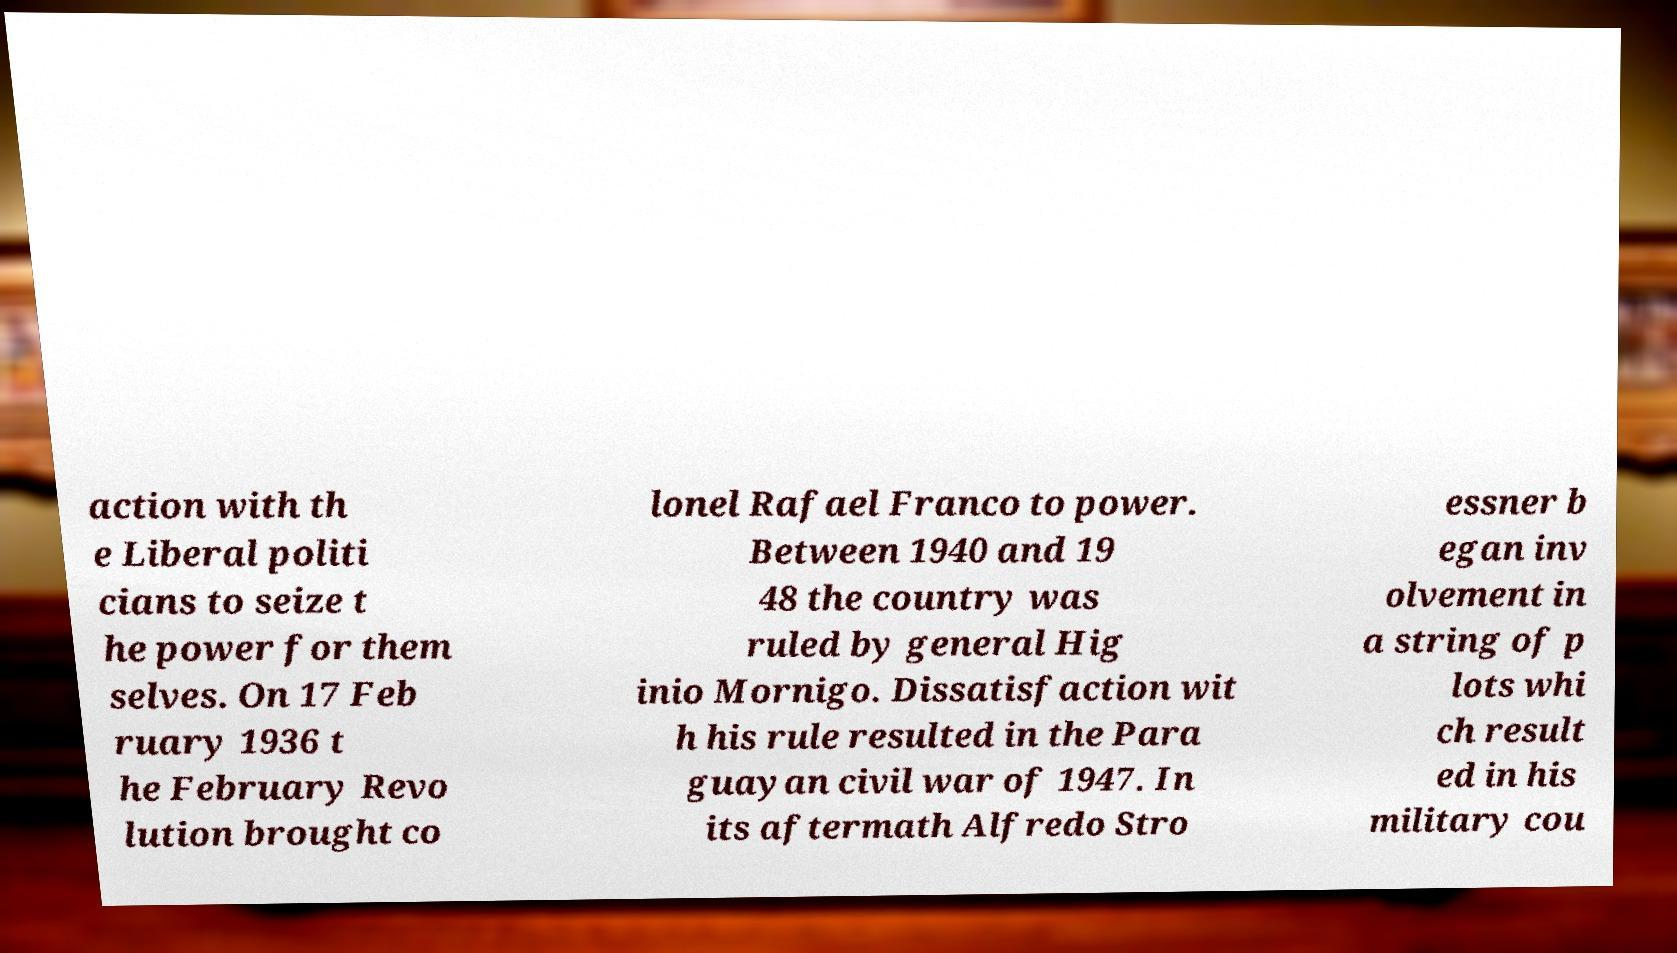Can you read and provide the text displayed in the image?This photo seems to have some interesting text. Can you extract and type it out for me? action with th e Liberal politi cians to seize t he power for them selves. On 17 Feb ruary 1936 t he February Revo lution brought co lonel Rafael Franco to power. Between 1940 and 19 48 the country was ruled by general Hig inio Mornigo. Dissatisfaction wit h his rule resulted in the Para guayan civil war of 1947. In its aftermath Alfredo Stro essner b egan inv olvement in a string of p lots whi ch result ed in his military cou 